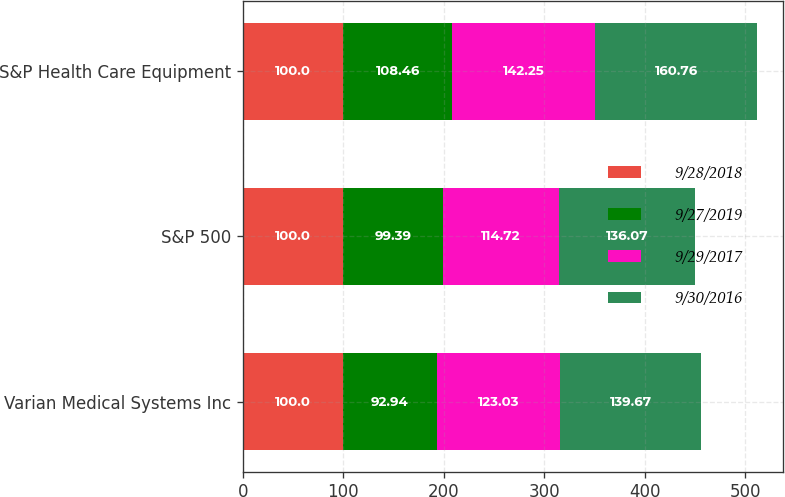Convert chart. <chart><loc_0><loc_0><loc_500><loc_500><stacked_bar_chart><ecel><fcel>Varian Medical Systems Inc<fcel>S&P 500<fcel>S&P Health Care Equipment<nl><fcel>9/28/2018<fcel>100<fcel>100<fcel>100<nl><fcel>9/27/2019<fcel>92.94<fcel>99.39<fcel>108.46<nl><fcel>9/29/2017<fcel>123.03<fcel>114.72<fcel>142.25<nl><fcel>9/30/2016<fcel>139.67<fcel>136.07<fcel>160.76<nl></chart> 